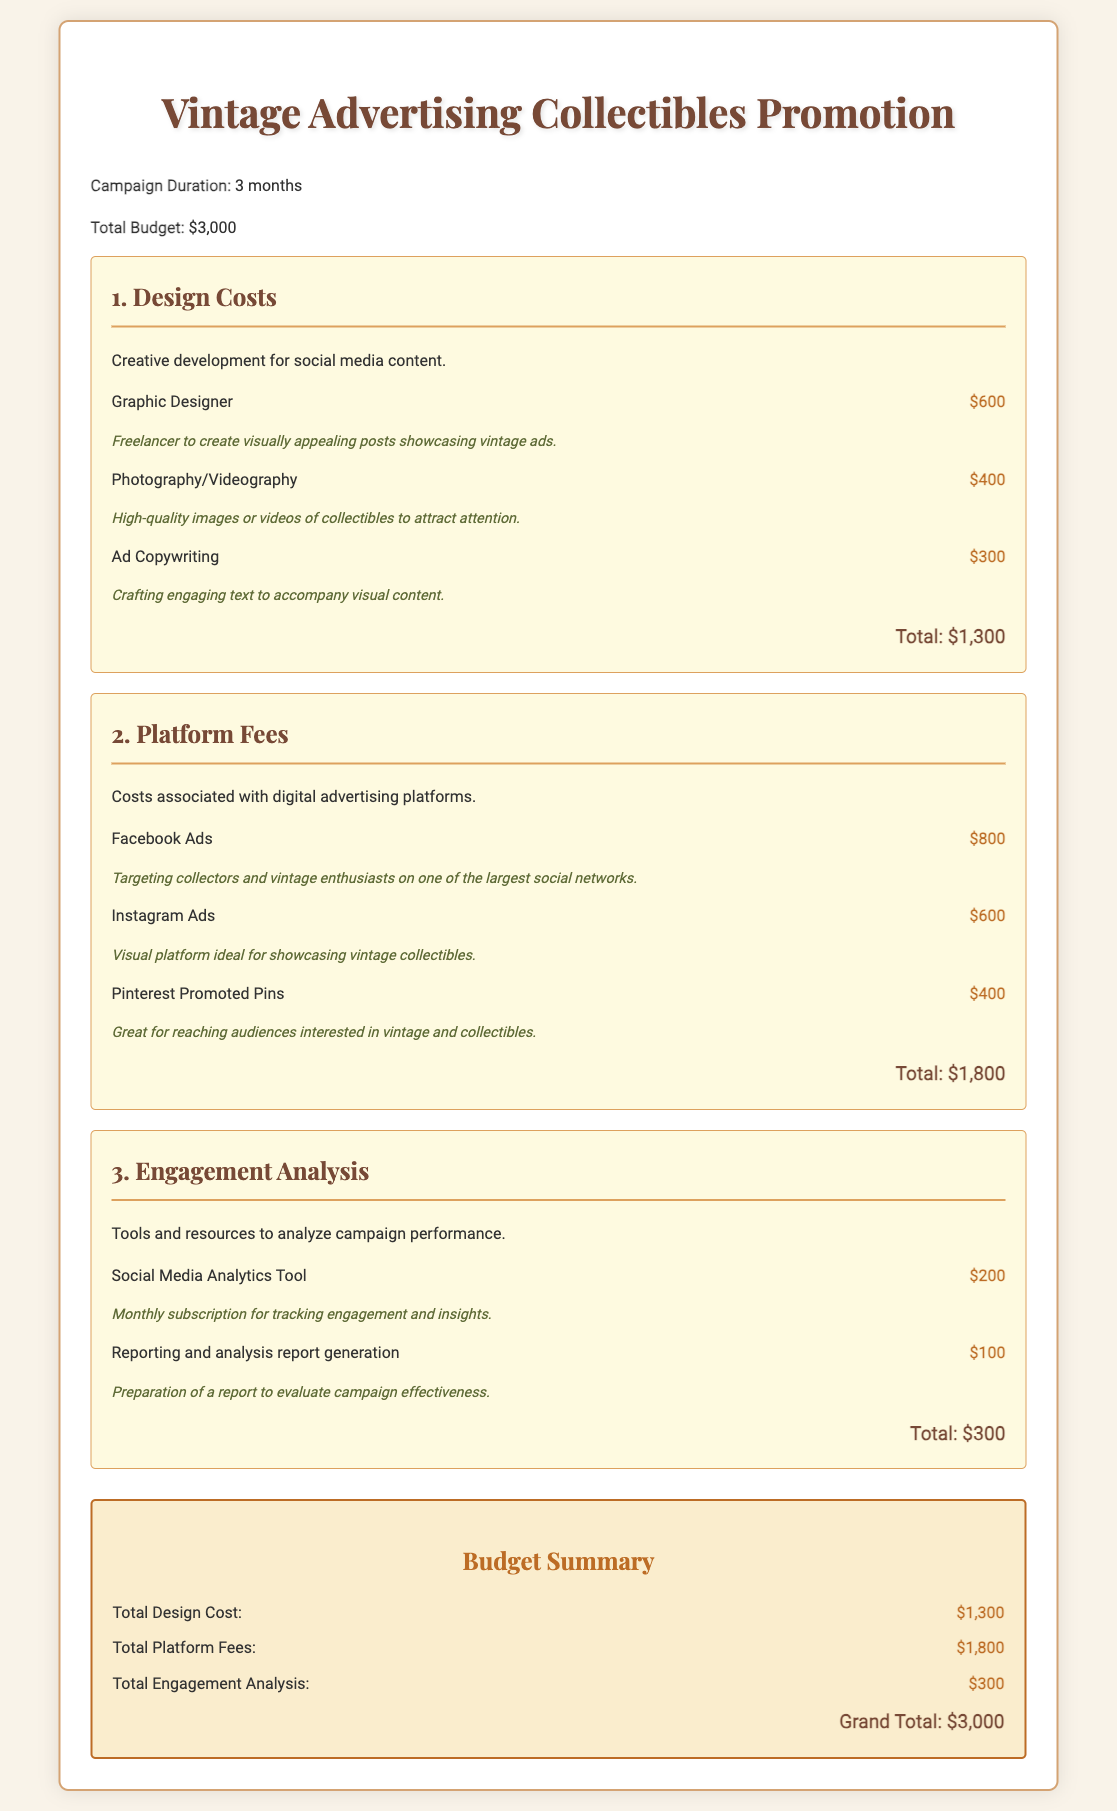what is the total budget for the campaign? The total budget is explicitly stated in the document as $3,000.
Answer: $3,000 how much is allocated for design costs? The total design cost is summed up in the design costs section, which amounts to $1,300.
Answer: $1,300 which platform has the highest advertising cost? The platform fees section indicates that Facebook Ads has the highest cost at $800.
Answer: Facebook Ads how much is spent on engagement analysis? The document specifies that the total cost for engagement analysis is $300.
Answer: $300 what percentage of the total budget is allocated to platform fees? Platform fees total $1,800, which is 60% of the total budget of $3,000.
Answer: 60% who is responsible for graphic design costs? The document indicates a Graphic Designer is responsible for these costs, with a fee of $600.
Answer: Graphic Designer what is the cost of ad copywriting? The cost for ad copywriting is listed as $300.
Answer: $300 how long is the campaign duration? The campaign duration is specified in the document as 3 months.
Answer: 3 months what is included in the design costs category? The design costs category includes Graphic Designer, Photography/Videography, and Ad Copywriting.
Answer: Graphic Designer, Photography/Videography, Ad Copywriting 